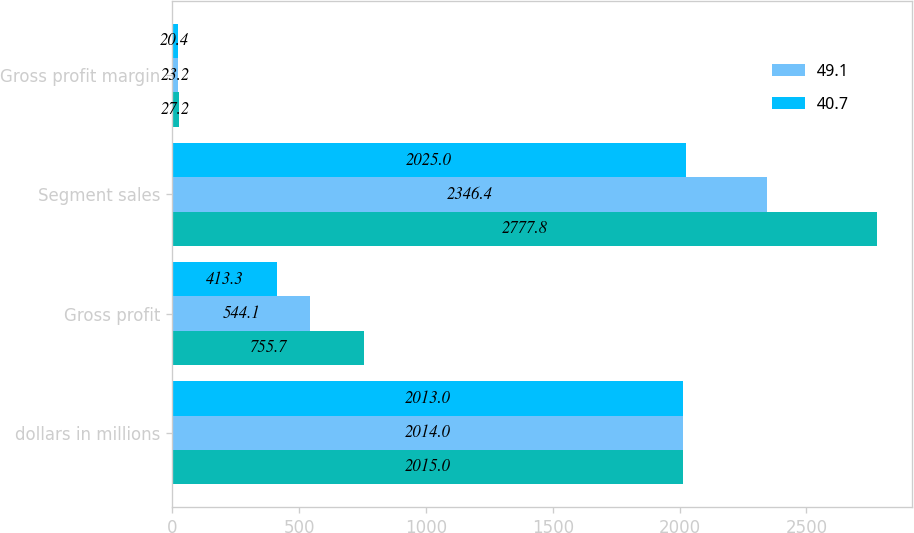Convert chart to OTSL. <chart><loc_0><loc_0><loc_500><loc_500><stacked_bar_chart><ecel><fcel>dollars in millions<fcel>Gross profit<fcel>Segment sales<fcel>Gross profit margin<nl><fcel>nan<fcel>2015<fcel>755.7<fcel>2777.8<fcel>27.2<nl><fcel>49.1<fcel>2014<fcel>544.1<fcel>2346.4<fcel>23.2<nl><fcel>40.7<fcel>2013<fcel>413.3<fcel>2025<fcel>20.4<nl></chart> 